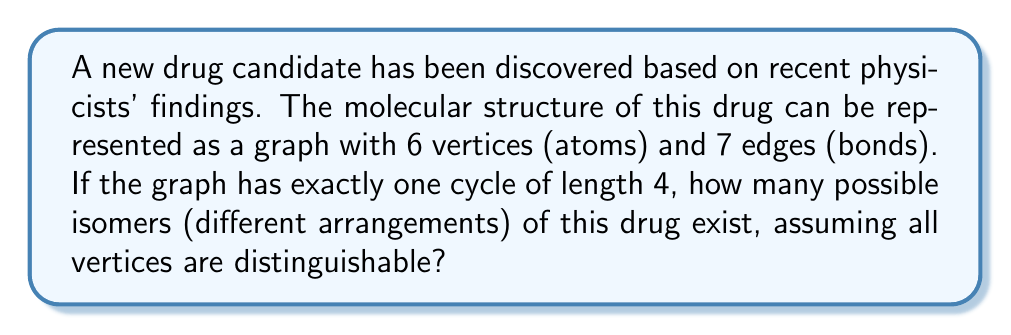Solve this math problem. Let's approach this step-by-step using graph theory:

1) First, we need to understand what the question is asking. We have a graph with:
   - 6 vertices (V = 6)
   - 7 edges (E = 7)
   - One cycle of length 4

2) The cycle of length 4 uses 4 vertices and 4 edges. This leaves us with:
   - 2 remaining vertices
   - 3 remaining edges

3) These remaining elements must form a tree structure, as any additional cycle would violate the given conditions.

4) To count the number of isomers, we need to consider all possible ways to arrange the remaining vertices and edges relative to the 4-cycle.

5) The 4-cycle can be considered fixed, as all cyclic permutations of its vertices result in the same structure. Let's label these vertices 1, 2, 3, 4.

6) Now, we need to count the ways to attach the remaining tree structure to the cycle. There are two cases:

   Case A: Both remaining vertices are attached directly to the cycle.
   - We can choose any 2 out of 4 vertices of the cycle to attach the remaining vertices.
   - This can be done in $\binom{4}{2} = 6$ ways.

   Case B: One vertex is attached to the cycle, and the other is attached to this vertex.
   - We can choose any 1 out of 4 vertices of the cycle to attach the first vertex.
   - This can be done in $\binom{4}{1} = 4$ ways.

7) The total number of isomers is the sum of these two cases: 6 + 4 = 10.

Therefore, there are 10 possible isomers of this drug molecule.
Answer: 10 isomers 